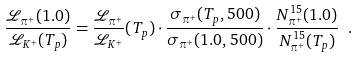<formula> <loc_0><loc_0><loc_500><loc_500>\frac { \mathcal { L } _ { \pi ^ { + } } ( 1 . 0 ) } { \mathcal { L } _ { K ^ { + } } ( T _ { p } ) } = \frac { \mathcal { L } _ { \pi ^ { + } } } { \mathcal { L } _ { K ^ { + } } } ( T _ { p } ) \cdot \frac { \sigma _ { \pi ^ { + } } ( T _ { p } , 5 0 0 ) } { \sigma _ { \pi ^ { + } } ( 1 . 0 , 5 0 0 ) } \cdot \frac { N _ { \pi ^ { + } } ^ { 1 5 } ( 1 . 0 ) } { N _ { \pi ^ { + } } ^ { 1 5 } ( T _ { p } ) } \ .</formula> 